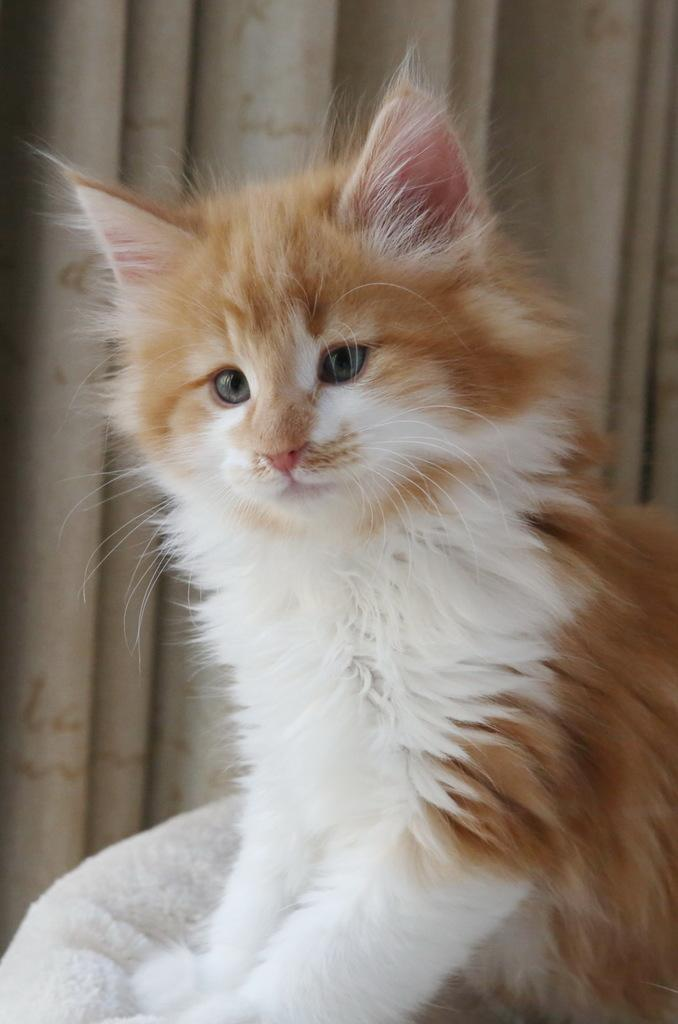What animal is present in the image? There is a cat in the picture. Where is the cat located in the image? The cat is sitting on a chair. What type of window treatment is visible in the image? There is a curtain visible in the image. What type of card can be seen floating in the ocean in the image? There is no card or ocean present in the image; it features a cat sitting on a chair with a curtain visible. 